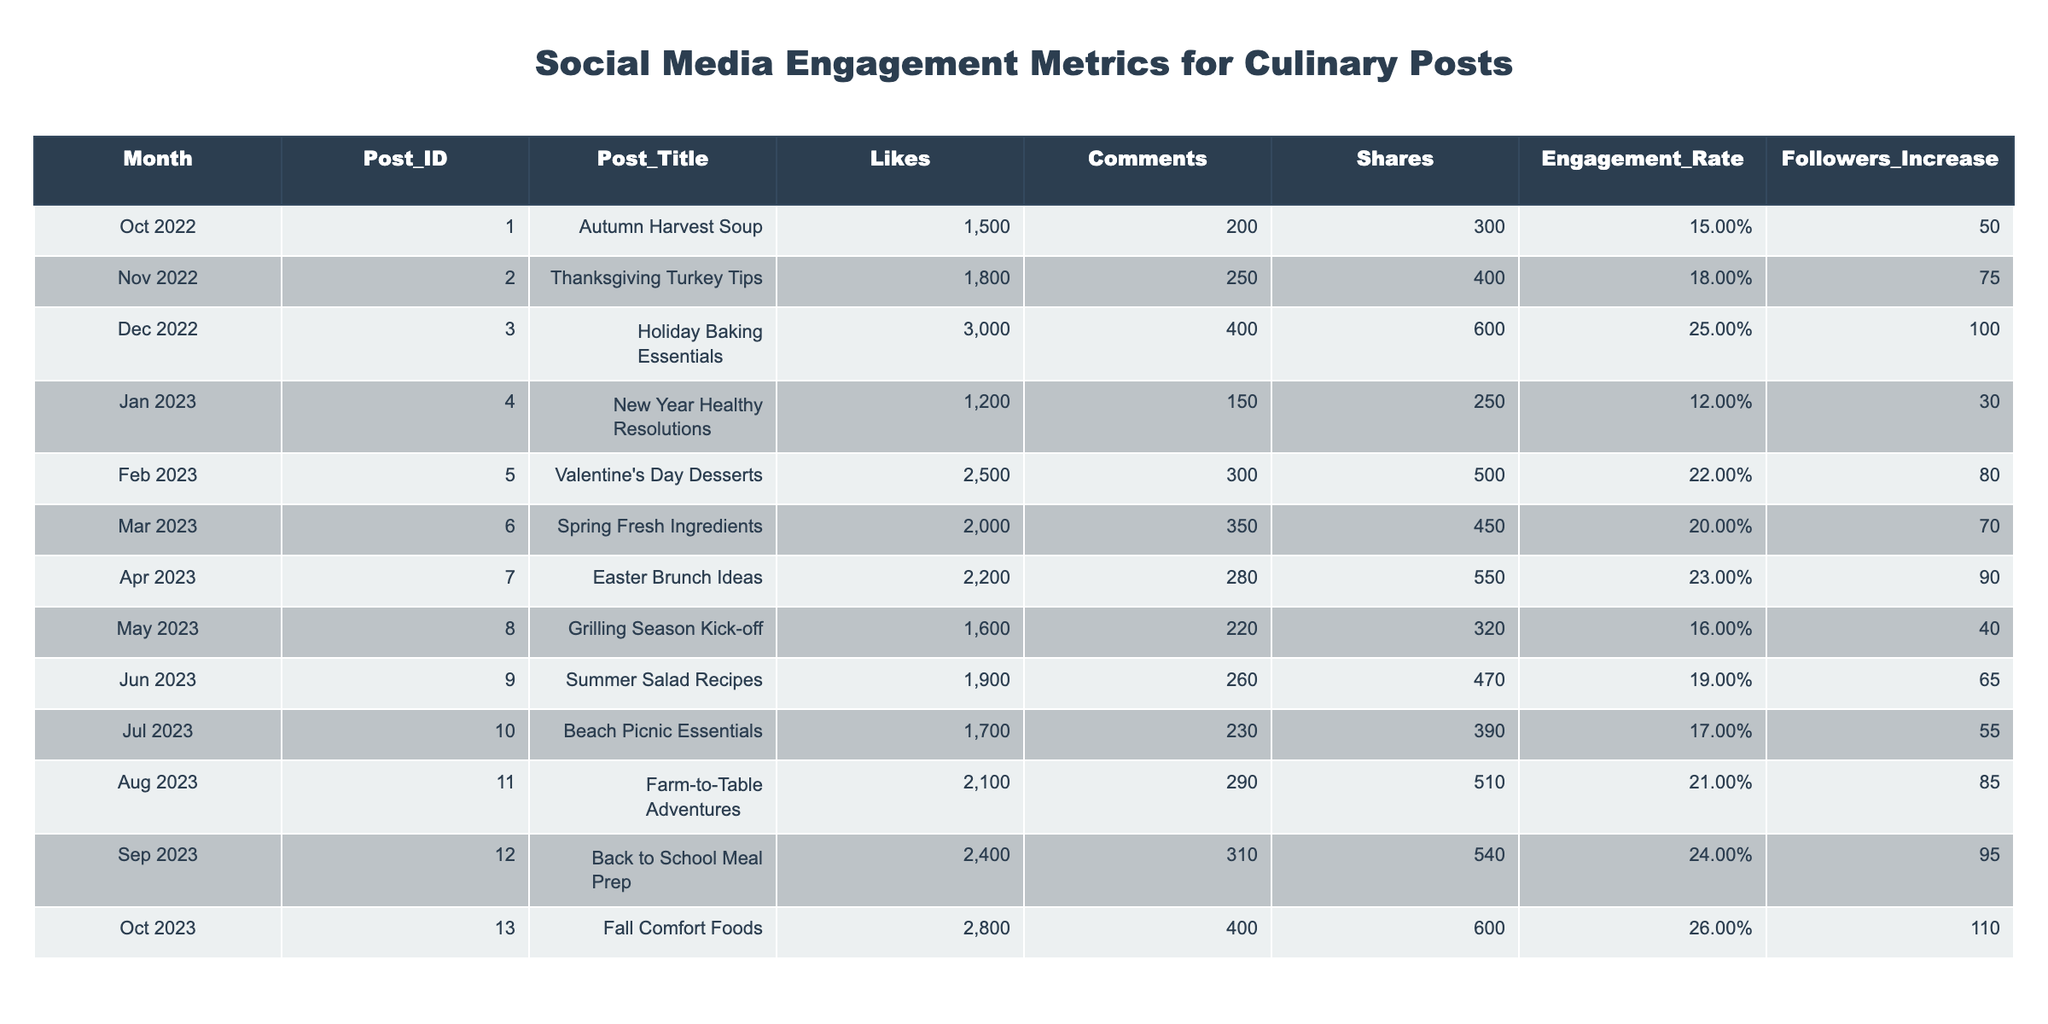What month had the highest engagement rate? Looking at the Engagement Rate column, the values are 0.15, 0.18, 0.25, 0.12, 0.22, 0.20, 0.23, 0.16, 0.19, 0.17, 0.21, 0.24, and 0.26. The highest value is 0.26, which corresponds to the month of October 2023.
Answer: October 2023 How many total likes were received for the chef's posts from January to March 2023? The likes received in January, February, and March are 1200, 2500, and 2000, respectively. Adding these together: 1200 + 2500 + 2000 = 5700.
Answer: 5700 Which post had the highest number of shares? From the Shares column, the values are 300, 400, 600, 250, 500, 450, 550, 320, 470, 390, 510, 540, and 600. The highest value is 600, which corresponds to both the Holiday Baking Essentials and Fall Comfort Foods posts.
Answer: Holiday Baking Essentials and Fall Comfort Foods Did the chef's followers increase after posting the Easter Brunch Ideas? After the Easter Brunch Ideas post in April, the Followers Increase is 90. This indicates that there was indeed an increase in followers after the post.
Answer: Yes What is the average number of comments for posts made between October 2022 and June 2023? The total number of comments from October 2022 through June 2023 are 200, 250, 400, 150, 300, 350, 280, 220. Adding these gives 2250, and with 8 posts, the average is 2250 / 8 = 281.25.
Answer: 281.25 Which month showed the highest increase in followers? The Followers Increase for each month is 50, 75, 100, 30, 80, 70, 90, 40, 65, 55, 85, 95, and 110. The highest increase is 110, which occurred in October 2023.
Answer: October 2023 What is the total engagement rate for all posts made in 2023? The engagement rates for 2023 are 0.12, 0.22, 0.20, 0.23, 0.16, 0.19, 0.17, 0.21, 0.24, and 0.26. The sum is 0.12 + 0.22 + 0.20 + 0.23 + 0.16 + 0.19 + 0.17 + 0.21 + 0.24 + 0.26 = 2.09. To find the average, divide by 10 (the number of posts) which gives 2.09 / 10 = 0.209.
Answer: 0.209 How does the engagement rate in September compare to the engagement rate in December of the previous year? The engagement rate in September 2023 is 0.24, while in December 2022 it is 0.25. The engagement rate in September is lower than that in December.
Answer: September's engagement rate is lower What was the average number of shares for all posts in 2022? The shares for 2022 are 300, 400, and 600. The total is 300 + 400 + 600 = 1300. Dividing this by the 3 posts gives an average of 1300 / 3 = 433.33.
Answer: 433.33 